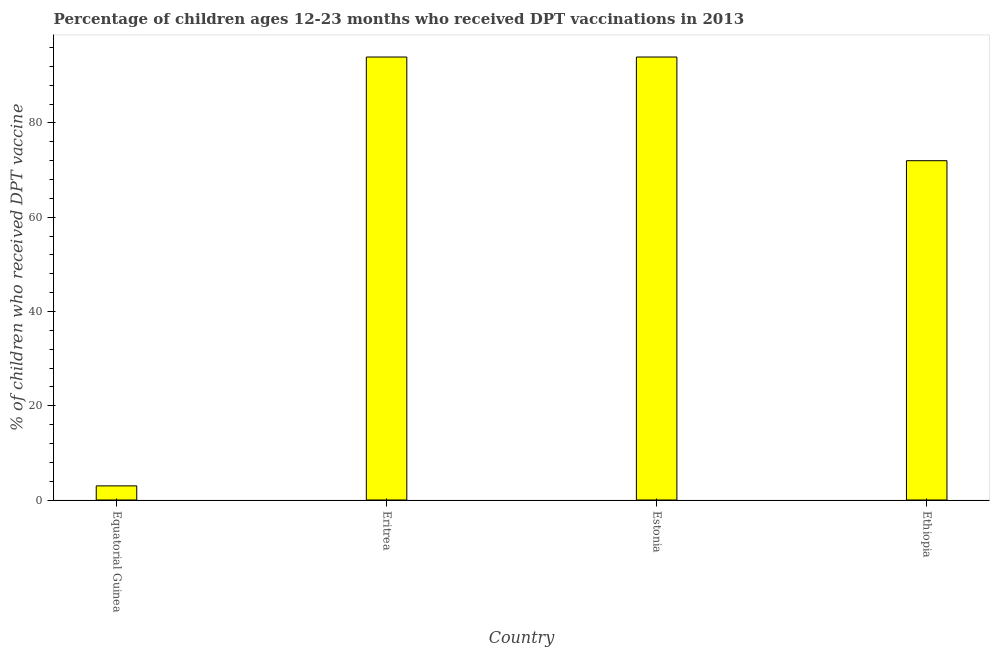Does the graph contain any zero values?
Make the answer very short. No. What is the title of the graph?
Your answer should be compact. Percentage of children ages 12-23 months who received DPT vaccinations in 2013. What is the label or title of the X-axis?
Your response must be concise. Country. What is the label or title of the Y-axis?
Your answer should be very brief. % of children who received DPT vaccine. Across all countries, what is the maximum percentage of children who received dpt vaccine?
Provide a short and direct response. 94. In which country was the percentage of children who received dpt vaccine maximum?
Give a very brief answer. Eritrea. In which country was the percentage of children who received dpt vaccine minimum?
Give a very brief answer. Equatorial Guinea. What is the sum of the percentage of children who received dpt vaccine?
Your answer should be compact. 263. What is the average percentage of children who received dpt vaccine per country?
Ensure brevity in your answer.  65.75. Is the percentage of children who received dpt vaccine in Eritrea less than that in Ethiopia?
Keep it short and to the point. No. What is the difference between the highest and the second highest percentage of children who received dpt vaccine?
Keep it short and to the point. 0. Is the sum of the percentage of children who received dpt vaccine in Equatorial Guinea and Estonia greater than the maximum percentage of children who received dpt vaccine across all countries?
Provide a succinct answer. Yes. What is the difference between the highest and the lowest percentage of children who received dpt vaccine?
Give a very brief answer. 91. How many bars are there?
Make the answer very short. 4. Are all the bars in the graph horizontal?
Your response must be concise. No. What is the % of children who received DPT vaccine in Equatorial Guinea?
Provide a short and direct response. 3. What is the % of children who received DPT vaccine in Eritrea?
Keep it short and to the point. 94. What is the % of children who received DPT vaccine of Estonia?
Your response must be concise. 94. What is the % of children who received DPT vaccine in Ethiopia?
Your answer should be compact. 72. What is the difference between the % of children who received DPT vaccine in Equatorial Guinea and Eritrea?
Your answer should be very brief. -91. What is the difference between the % of children who received DPT vaccine in Equatorial Guinea and Estonia?
Your response must be concise. -91. What is the difference between the % of children who received DPT vaccine in Equatorial Guinea and Ethiopia?
Provide a short and direct response. -69. What is the difference between the % of children who received DPT vaccine in Eritrea and Ethiopia?
Provide a short and direct response. 22. What is the ratio of the % of children who received DPT vaccine in Equatorial Guinea to that in Eritrea?
Offer a terse response. 0.03. What is the ratio of the % of children who received DPT vaccine in Equatorial Guinea to that in Estonia?
Keep it short and to the point. 0.03. What is the ratio of the % of children who received DPT vaccine in Equatorial Guinea to that in Ethiopia?
Give a very brief answer. 0.04. What is the ratio of the % of children who received DPT vaccine in Eritrea to that in Estonia?
Give a very brief answer. 1. What is the ratio of the % of children who received DPT vaccine in Eritrea to that in Ethiopia?
Provide a succinct answer. 1.31. What is the ratio of the % of children who received DPT vaccine in Estonia to that in Ethiopia?
Provide a short and direct response. 1.31. 